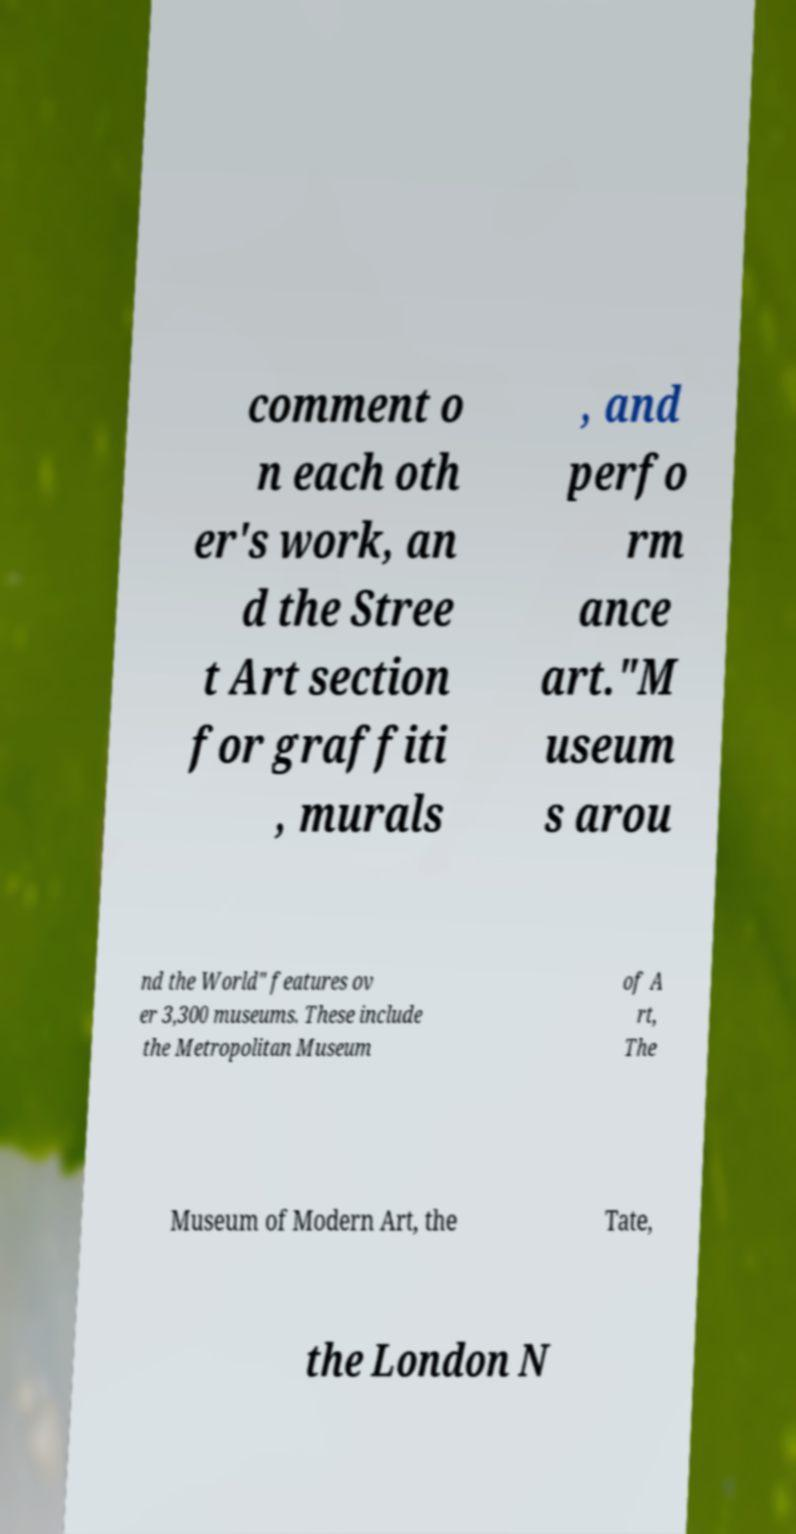Could you extract and type out the text from this image? comment o n each oth er's work, an d the Stree t Art section for graffiti , murals , and perfo rm ance art."M useum s arou nd the World" features ov er 3,300 museums. These include the Metropolitan Museum of A rt, The Museum of Modern Art, the Tate, the London N 